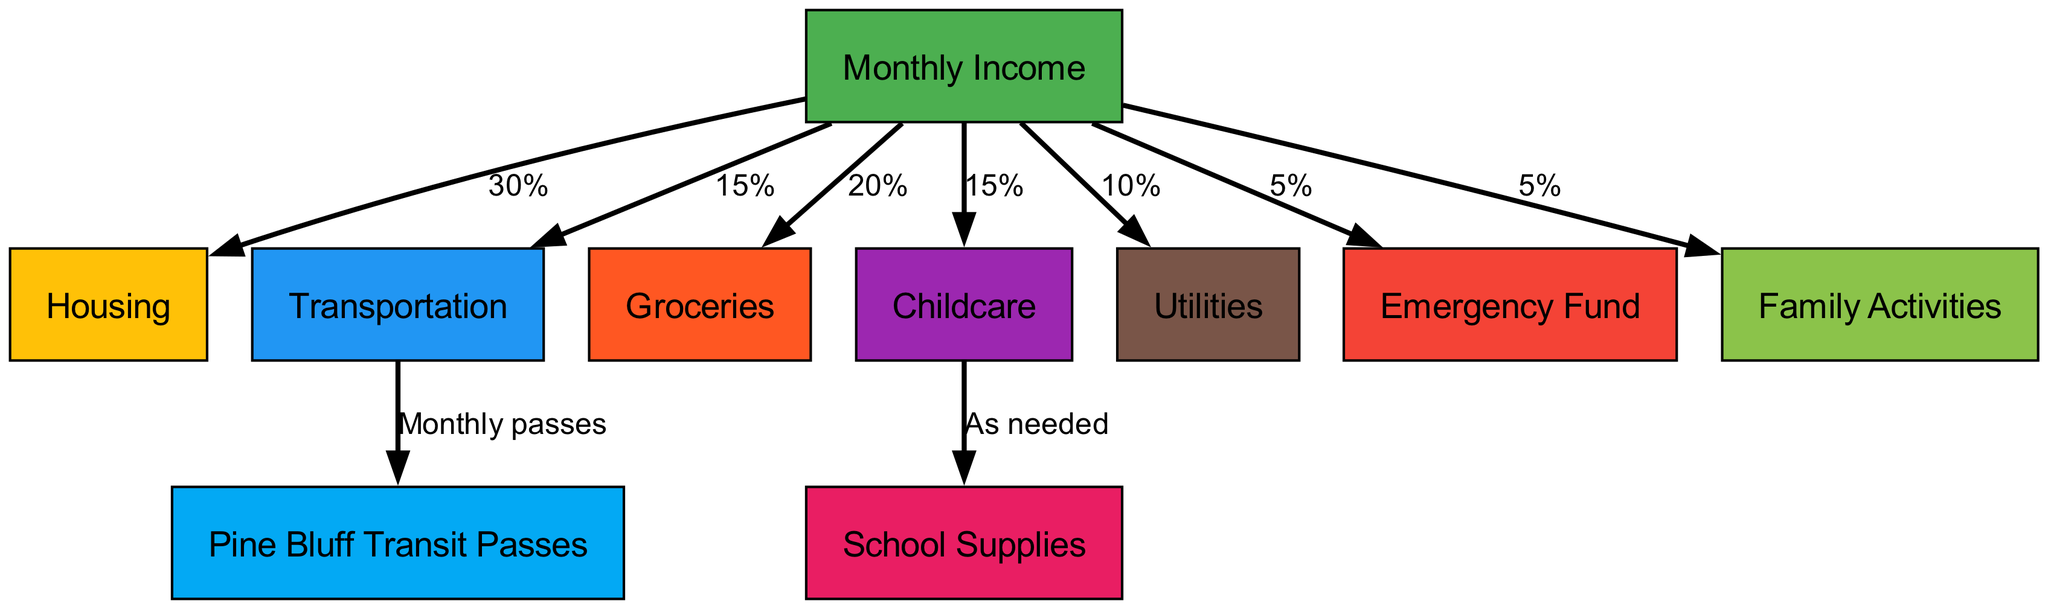What is the percentage of monthly income allocated to Housing? The diagram shows that from the "Monthly Income" node, there is a directed edge leading to "Housing" with a label of "30%". Therefore, the allocation for Housing is directly represented as 30%.
Answer: 30% How many nodes are present in the diagram? The nodes listed in the data include: Monthly Income, Housing, Transportation, Groceries, Childcare, Utilities, Pine Bluff Transit Passes, School Supplies, Emergency Fund, and Family Activities. Counting all these unique entries gives a total of 10 nodes in the diagram.
Answer: 10 What percentage of the monthly income is allocated to Groceries? The edge from "Monthly Income" to "Groceries" shows a label indicating it is "20%". Thus, this is the amount set aside for Groceries from the monthly income.
Answer: 20% Which node receives funding from Childcare? The edge from the "Childcare" node points to "School Supplies", meaning that School Supplies are funded by Childcare as indicated in the diagram.
Answer: School Supplies What is the relationship between Transportation and Pine Bluff Transit Passes? The directed edge originates from the "Transportation" node leading to "Pine Bluff Transit Passes" with the label "Monthly passes", showcasing that the funding for Pine Bluff Transit Passes is a subset of the larger Transportation category.
Answer: Monthly passes What is the total percentage allocated to the Emergency Fund and Family Activities combined? The diagram shows that "Emergency Fund" is allocated 5% and "Family Activities" is also allocated 5% directly from "Monthly Income". Adding these percentages gives a total of 10%.
Answer: 10% What is the sum of percentages allocated to Housing and Utilities? The "Housing" node has a percentage allocation of 30% and the "Utilities" node has 10%. By summing these two percentages together, we arrive at a total of 40%.
Answer: 40% How many edges are there in the directed graph? The edges are detailed by the connections listed in the data. There are 8 connections noted, which include those from monthly income and the relationships from Childcare and Transportation to their respective nodes. Counting all specified edges gives a total of 8.
Answer: 8 Which category has the highest percentage allocation from Monthly Income? Reviewing the allocation percentages from "Monthly Income", the highest allocation is 30% towards "Housing", which is the largest individual percentage in the diagram.
Answer: Housing 